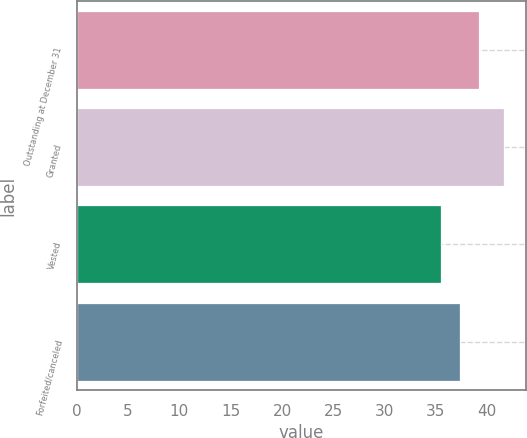Convert chart to OTSL. <chart><loc_0><loc_0><loc_500><loc_500><bar_chart><fcel>Outstanding at December 31<fcel>Granted<fcel>Vested<fcel>Forfeited/canceled<nl><fcel>39.22<fcel>41.66<fcel>35.52<fcel>37.38<nl></chart> 